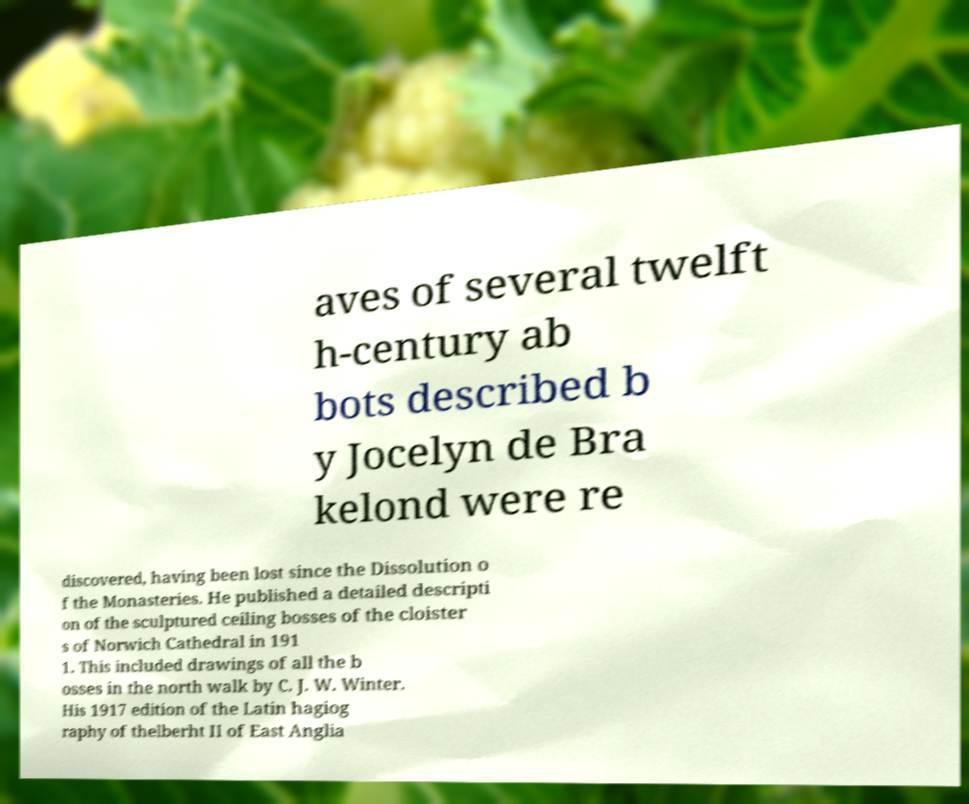I need the written content from this picture converted into text. Can you do that? aves of several twelft h-century ab bots described b y Jocelyn de Bra kelond were re discovered, having been lost since the Dissolution o f the Monasteries. He published a detailed descripti on of the sculptured ceiling bosses of the cloister s of Norwich Cathedral in 191 1. This included drawings of all the b osses in the north walk by C. J. W. Winter. His 1917 edition of the Latin hagiog raphy of thelberht II of East Anglia 